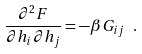<formula> <loc_0><loc_0><loc_500><loc_500>\frac { \partial ^ { 2 } F } { \partial h _ { i } \partial h _ { j } } = - \beta G _ { i j } \ .</formula> 